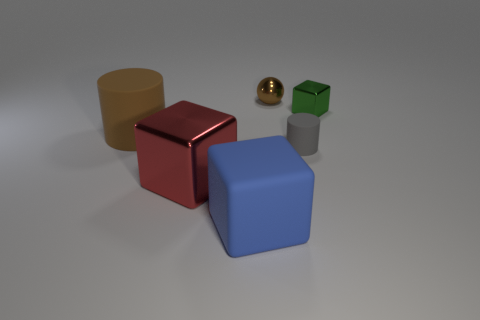There is a brown object that is to the left of the blue block; is its size the same as the rubber object that is right of the brown sphere?
Keep it short and to the point. No. Are there more blue things than cylinders?
Your response must be concise. No. How many blue objects are made of the same material as the large red cube?
Make the answer very short. 0. Do the gray thing and the large brown thing have the same shape?
Keep it short and to the point. Yes. What is the size of the brown thing that is to the left of the metal thing that is in front of the brown object that is left of the large blue rubber block?
Keep it short and to the point. Large. Are there any tiny gray objects that are behind the shiny block on the left side of the big blue rubber cube?
Provide a succinct answer. Yes. How many things are behind the cube that is on the left side of the big matte object on the right side of the big metal block?
Provide a short and direct response. 4. There is a thing that is both on the left side of the large blue object and behind the big red thing; what is its color?
Ensure brevity in your answer.  Brown. What number of metal objects are the same color as the big rubber cylinder?
Provide a succinct answer. 1. What number of cubes are green shiny objects or red things?
Your answer should be very brief. 2. 